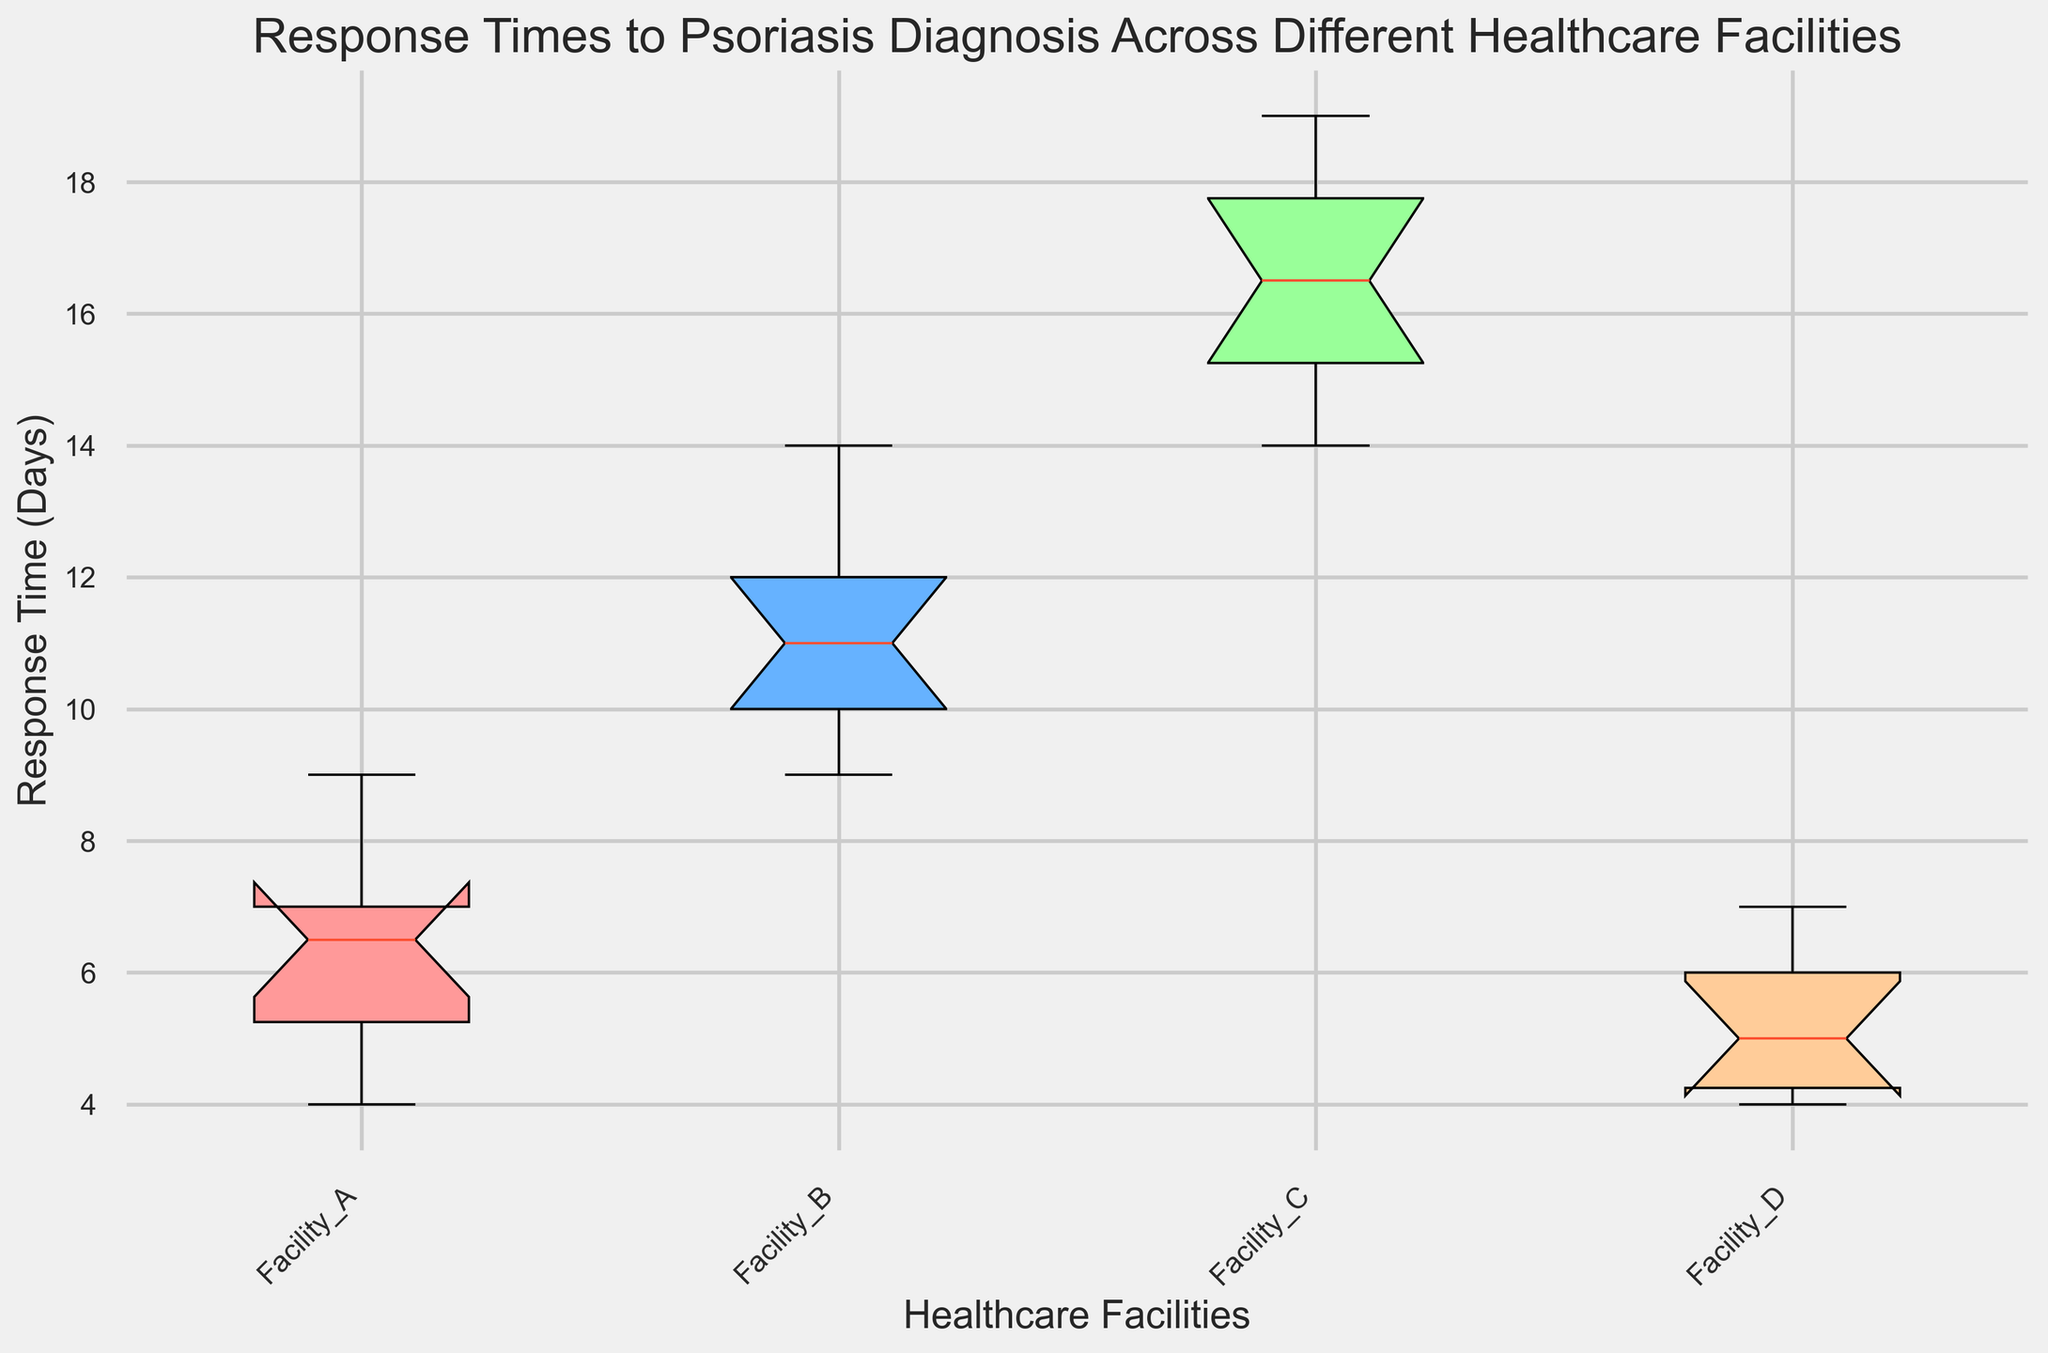What's the median response time for Facility C? To find the median response time for Facility C, look at the boxplot for Facility C and identify the middle value of the dataset marked by a horizontal line inside the box.
Answer: 16 Which facility has the lowest median response time? Compare the positions of the median lines (horizontal lines inside the boxes) across all facilities. The facility with the lowest median line on the y-axis has the lowest median response time.
Answer: Facility D Are there any outliers in the response times for Facility A? Outliers in a boxplot are typically marked as individual points outside the whiskers of the boxplot. Look for any such points in the boxplot for Facility A.
Answer: No Which facility has the highest interquartile range (IQR)? The IQR is the range between the first quartile (Q1) and the third quartile (Q3) and is visualized by the height of the box. The facility with the tallest box has the highest IQR.
Answer: Facility C Compare the maximum response times between Facility B and Facility D. Find the top whiskers in the boxplots of Facility B and Facility D, and compare their lengths to identify the higher value.
Answer: Facility B What is the range of response times for Facility D? The range can be calculated by subtracting the minimum value (lowest whisker) from the maximum value (highest whisker) in the boxplot of Facility D.
Answer: 3 Which facility has the most consistent response times? Consistent response times will have a smaller range and IQR. Identify the facility with the smallest box and shortest whiskers.
Answer: Facility D How does the median response time of Facility A compare to that of Facility B? Compare the positions of the median lines (horizontal lines inside the boxes) between Facility A and Facility B.
Answer: Facility A's median is lower than Facility B's Can we infer any trend regarding the response times across these facilities? Analyze the medians, ranges, and IQRs of all facilities to identify any patterns or trends in response times. For example, if higher facilities have longer medians and IQRs.
Answer: Facilities with higher labels tend to have longer response times What are the whiskers in a boxplot indicating in general? The whiskers indicate the range of the data excluding outliers, typically extending to 1.5 times the IQR from the quartiles. Check the positioning of whiskers to understand the data spread.
Answer: Range excluding outliers 